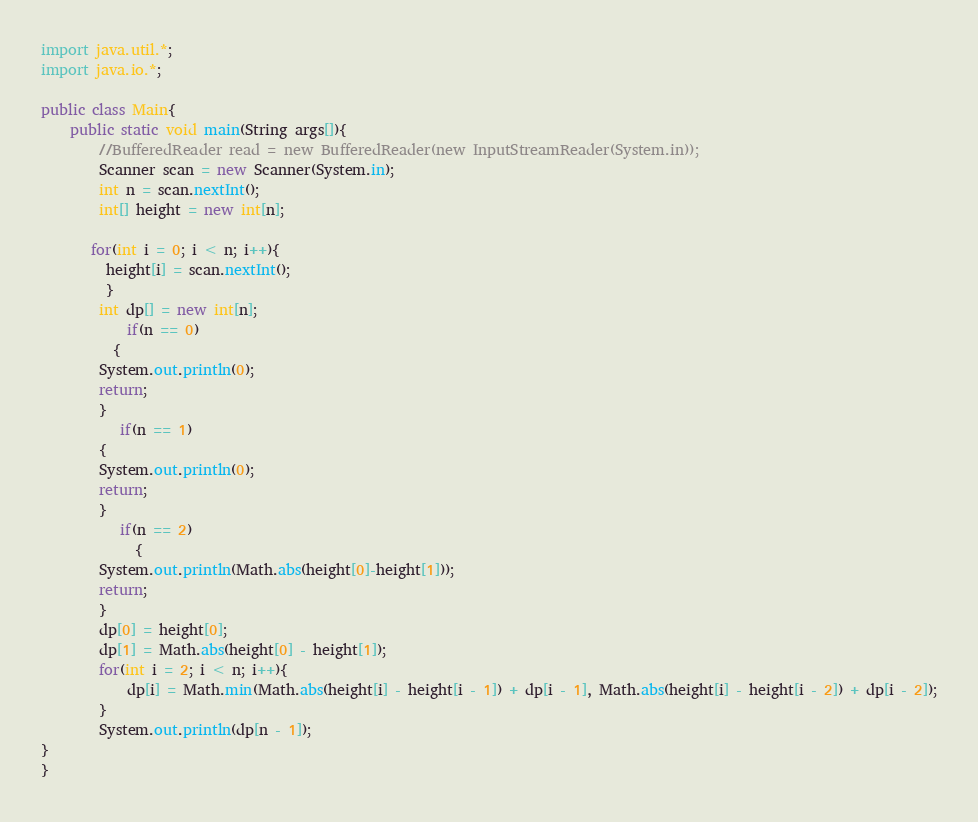Convert code to text. <code><loc_0><loc_0><loc_500><loc_500><_Java_>import java.util.*;
import java.io.*;

public class Main{
	public static void main(String args[]){
		//BufferedReader read = new BufferedReader(new InputStreamReader(System.in));
		Scanner scan = new Scanner(System.in);
		int n = scan.nextInt();
		int[] height = new int[n];
		
	   for(int i = 0; i < n; i++){
         height[i] = scan.nextInt();
         }
		int dp[] = new int[n];
	    	if(n == 0)
          {
	    System.out.println(0);
	    return;
	    }
	       if(n == 1)
	    {     	
	    System.out.println(0);
	    return;
	    }
	       if(n == 2)
	         {
	    System.out.println(Math.abs(height[0]-height[1]));
	    return;
		}
		dp[0] = height[0];
		dp[1] = Math.abs(height[0] - height[1]);
		for(int i = 2; i < n; i++){
			dp[i] = Math.min(Math.abs(height[i] - height[i - 1]) + dp[i - 1], Math.abs(height[i] - height[i - 2]) + dp[i - 2]);
		}
		System.out.println(dp[n - 1]); 
}
}</code> 